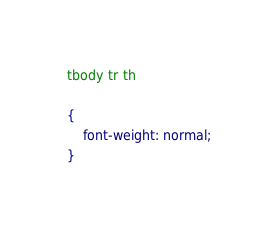<code> <loc_0><loc_0><loc_500><loc_500><_CSS_>
tbody tr th

{
    font-weight: normal;
}
</code> 